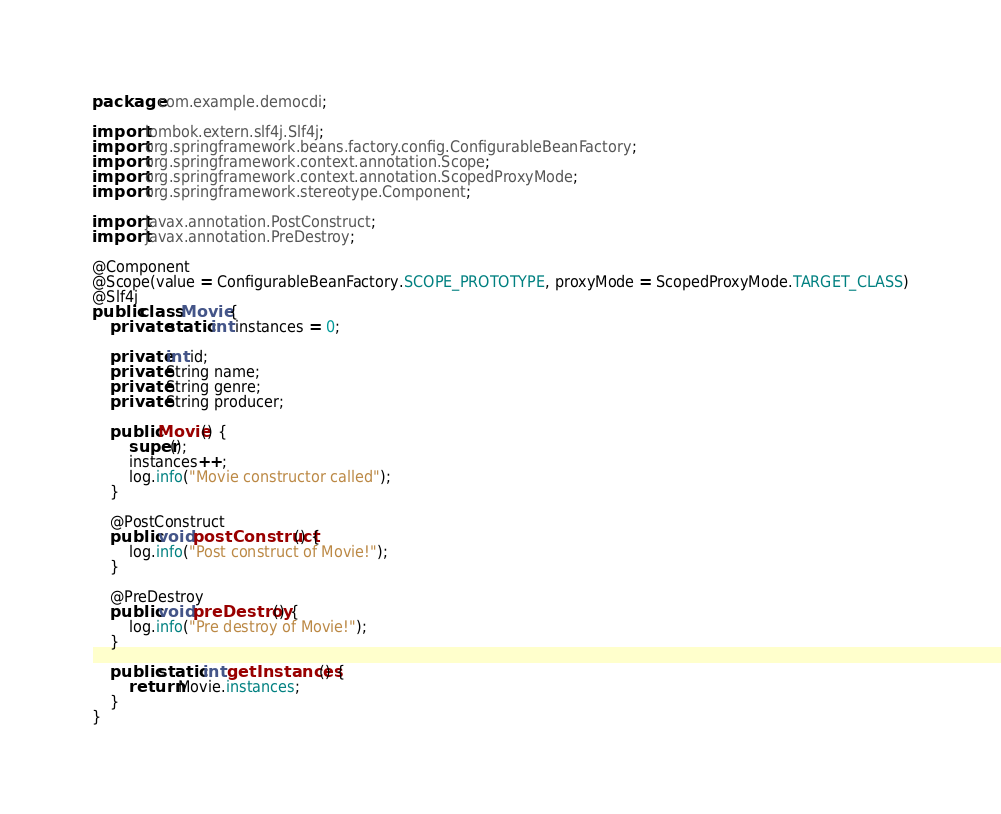<code> <loc_0><loc_0><loc_500><loc_500><_Java_>package com.example.democdi;

import lombok.extern.slf4j.Slf4j;
import org.springframework.beans.factory.config.ConfigurableBeanFactory;
import org.springframework.context.annotation.Scope;
import org.springframework.context.annotation.ScopedProxyMode;
import org.springframework.stereotype.Component;

import javax.annotation.PostConstruct;
import javax.annotation.PreDestroy;

@Component
@Scope(value = ConfigurableBeanFactory.SCOPE_PROTOTYPE, proxyMode = ScopedProxyMode.TARGET_CLASS)
@Slf4j
public class Movie {
    private static int instances = 0;

    private int id;
    private String name;
    private String genre;
    private String producer;

    public Movie() {
        super();
        instances++;
        log.info("Movie constructor called");
    }

    @PostConstruct
    public void postConstruct() {
        log.info("Post construct of Movie!");
    }

    @PreDestroy
    public void preDestroy() {
        log.info("Pre destroy of Movie!");
    }

    public static int getInstances() {
        return Movie.instances;
    }
}
</code> 